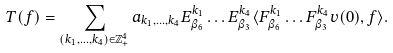Convert formula to latex. <formula><loc_0><loc_0><loc_500><loc_500>T ( f ) = \sum _ { ( k _ { 1 } , \dots , k _ { 4 } ) \in \mathbb { Z } _ { + } ^ { 4 } } a _ { k _ { 1 } , \dots , k _ { 4 } } E ^ { k _ { 1 } } _ { \beta _ { 6 } } \dots E ^ { k _ { 4 } } _ { \beta _ { 3 } } \langle F ^ { k _ { 1 } } _ { \beta _ { 6 } } \dots F ^ { k _ { 4 } } _ { \beta _ { 3 } } v ( 0 ) , f \rangle .</formula> 